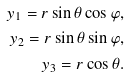<formula> <loc_0><loc_0><loc_500><loc_500>y _ { 1 } = r \sin \theta \cos \varphi , \\ y _ { 2 } = r \sin \theta \sin \varphi , \\ y _ { 3 } = r \cos \theta .</formula> 